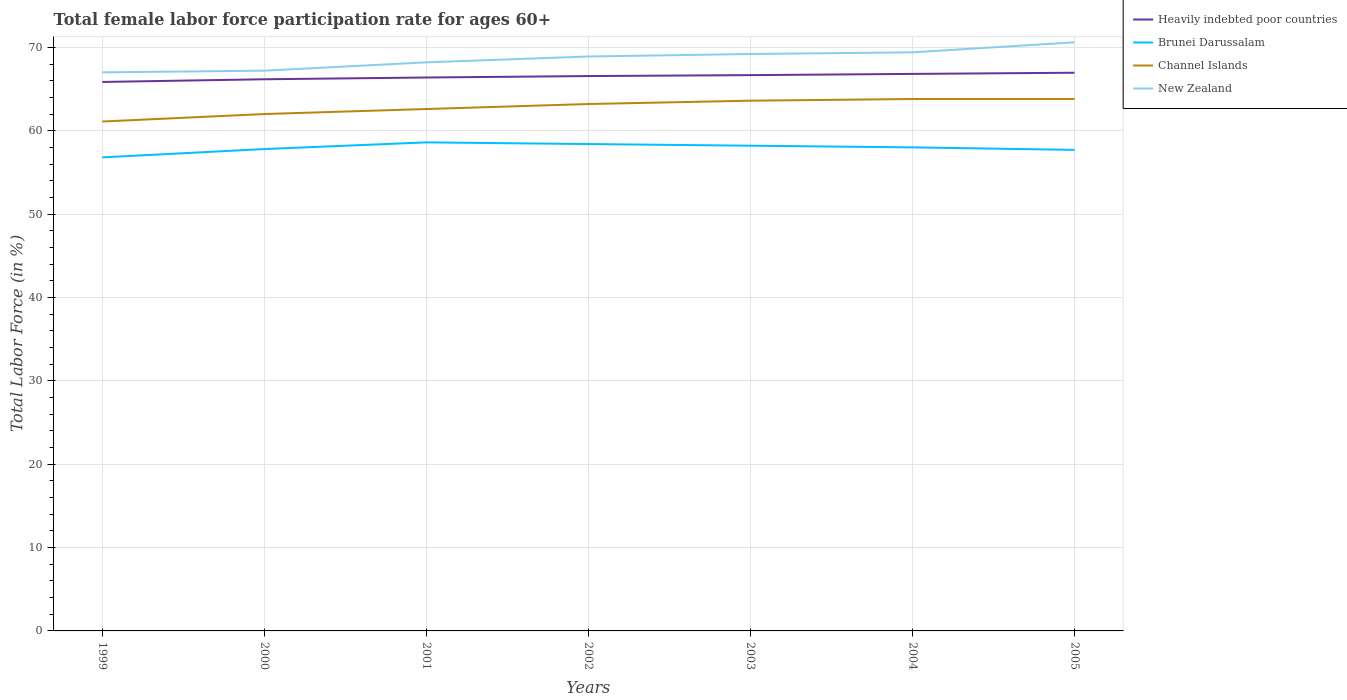Does the line corresponding to Brunei Darussalam intersect with the line corresponding to New Zealand?
Ensure brevity in your answer.  No. Across all years, what is the maximum female labor force participation rate in Channel Islands?
Give a very brief answer. 61.1. In which year was the female labor force participation rate in Brunei Darussalam maximum?
Provide a succinct answer. 1999. What is the total female labor force participation rate in Channel Islands in the graph?
Your response must be concise. -1.6. What is the difference between the highest and the second highest female labor force participation rate in Brunei Darussalam?
Make the answer very short. 1.8. How many lines are there?
Provide a succinct answer. 4. How many years are there in the graph?
Give a very brief answer. 7. Are the values on the major ticks of Y-axis written in scientific E-notation?
Your response must be concise. No. What is the title of the graph?
Give a very brief answer. Total female labor force participation rate for ages 60+. What is the label or title of the Y-axis?
Ensure brevity in your answer.  Total Labor Force (in %). What is the Total Labor Force (in %) of Heavily indebted poor countries in 1999?
Ensure brevity in your answer.  65.85. What is the Total Labor Force (in %) of Brunei Darussalam in 1999?
Ensure brevity in your answer.  56.8. What is the Total Labor Force (in %) of Channel Islands in 1999?
Ensure brevity in your answer.  61.1. What is the Total Labor Force (in %) of New Zealand in 1999?
Your response must be concise. 67. What is the Total Labor Force (in %) of Heavily indebted poor countries in 2000?
Provide a succinct answer. 66.17. What is the Total Labor Force (in %) of Brunei Darussalam in 2000?
Give a very brief answer. 57.8. What is the Total Labor Force (in %) of Channel Islands in 2000?
Offer a terse response. 62. What is the Total Labor Force (in %) in New Zealand in 2000?
Your response must be concise. 67.2. What is the Total Labor Force (in %) in Heavily indebted poor countries in 2001?
Offer a terse response. 66.38. What is the Total Labor Force (in %) of Brunei Darussalam in 2001?
Keep it short and to the point. 58.6. What is the Total Labor Force (in %) in Channel Islands in 2001?
Offer a terse response. 62.6. What is the Total Labor Force (in %) in New Zealand in 2001?
Make the answer very short. 68.2. What is the Total Labor Force (in %) in Heavily indebted poor countries in 2002?
Offer a terse response. 66.55. What is the Total Labor Force (in %) in Brunei Darussalam in 2002?
Offer a terse response. 58.4. What is the Total Labor Force (in %) of Channel Islands in 2002?
Ensure brevity in your answer.  63.2. What is the Total Labor Force (in %) of New Zealand in 2002?
Keep it short and to the point. 68.9. What is the Total Labor Force (in %) in Heavily indebted poor countries in 2003?
Ensure brevity in your answer.  66.67. What is the Total Labor Force (in %) of Brunei Darussalam in 2003?
Provide a succinct answer. 58.2. What is the Total Labor Force (in %) in Channel Islands in 2003?
Provide a succinct answer. 63.6. What is the Total Labor Force (in %) in New Zealand in 2003?
Ensure brevity in your answer.  69.2. What is the Total Labor Force (in %) of Heavily indebted poor countries in 2004?
Your answer should be very brief. 66.81. What is the Total Labor Force (in %) in Brunei Darussalam in 2004?
Ensure brevity in your answer.  58. What is the Total Labor Force (in %) in Channel Islands in 2004?
Keep it short and to the point. 63.8. What is the Total Labor Force (in %) in New Zealand in 2004?
Provide a succinct answer. 69.4. What is the Total Labor Force (in %) of Heavily indebted poor countries in 2005?
Ensure brevity in your answer.  66.95. What is the Total Labor Force (in %) of Brunei Darussalam in 2005?
Provide a succinct answer. 57.7. What is the Total Labor Force (in %) in Channel Islands in 2005?
Give a very brief answer. 63.8. What is the Total Labor Force (in %) in New Zealand in 2005?
Give a very brief answer. 70.6. Across all years, what is the maximum Total Labor Force (in %) in Heavily indebted poor countries?
Offer a terse response. 66.95. Across all years, what is the maximum Total Labor Force (in %) in Brunei Darussalam?
Give a very brief answer. 58.6. Across all years, what is the maximum Total Labor Force (in %) of Channel Islands?
Your answer should be very brief. 63.8. Across all years, what is the maximum Total Labor Force (in %) of New Zealand?
Ensure brevity in your answer.  70.6. Across all years, what is the minimum Total Labor Force (in %) of Heavily indebted poor countries?
Your answer should be compact. 65.85. Across all years, what is the minimum Total Labor Force (in %) of Brunei Darussalam?
Ensure brevity in your answer.  56.8. Across all years, what is the minimum Total Labor Force (in %) in Channel Islands?
Provide a succinct answer. 61.1. What is the total Total Labor Force (in %) in Heavily indebted poor countries in the graph?
Your answer should be compact. 465.38. What is the total Total Labor Force (in %) in Brunei Darussalam in the graph?
Provide a short and direct response. 405.5. What is the total Total Labor Force (in %) in Channel Islands in the graph?
Make the answer very short. 440.1. What is the total Total Labor Force (in %) of New Zealand in the graph?
Make the answer very short. 480.5. What is the difference between the Total Labor Force (in %) in Heavily indebted poor countries in 1999 and that in 2000?
Make the answer very short. -0.32. What is the difference between the Total Labor Force (in %) of Channel Islands in 1999 and that in 2000?
Give a very brief answer. -0.9. What is the difference between the Total Labor Force (in %) of New Zealand in 1999 and that in 2000?
Give a very brief answer. -0.2. What is the difference between the Total Labor Force (in %) of Heavily indebted poor countries in 1999 and that in 2001?
Provide a short and direct response. -0.53. What is the difference between the Total Labor Force (in %) in Channel Islands in 1999 and that in 2001?
Your response must be concise. -1.5. What is the difference between the Total Labor Force (in %) of New Zealand in 1999 and that in 2001?
Provide a succinct answer. -1.2. What is the difference between the Total Labor Force (in %) of Heavily indebted poor countries in 1999 and that in 2002?
Ensure brevity in your answer.  -0.71. What is the difference between the Total Labor Force (in %) in Channel Islands in 1999 and that in 2002?
Give a very brief answer. -2.1. What is the difference between the Total Labor Force (in %) of New Zealand in 1999 and that in 2002?
Keep it short and to the point. -1.9. What is the difference between the Total Labor Force (in %) in Heavily indebted poor countries in 1999 and that in 2003?
Give a very brief answer. -0.82. What is the difference between the Total Labor Force (in %) of New Zealand in 1999 and that in 2003?
Your answer should be very brief. -2.2. What is the difference between the Total Labor Force (in %) in Heavily indebted poor countries in 1999 and that in 2004?
Offer a terse response. -0.96. What is the difference between the Total Labor Force (in %) in Channel Islands in 1999 and that in 2004?
Give a very brief answer. -2.7. What is the difference between the Total Labor Force (in %) of New Zealand in 1999 and that in 2004?
Provide a short and direct response. -2.4. What is the difference between the Total Labor Force (in %) in Heavily indebted poor countries in 1999 and that in 2005?
Keep it short and to the point. -1.11. What is the difference between the Total Labor Force (in %) in Brunei Darussalam in 1999 and that in 2005?
Make the answer very short. -0.9. What is the difference between the Total Labor Force (in %) of New Zealand in 1999 and that in 2005?
Provide a short and direct response. -3.6. What is the difference between the Total Labor Force (in %) in Heavily indebted poor countries in 2000 and that in 2001?
Provide a short and direct response. -0.21. What is the difference between the Total Labor Force (in %) of Brunei Darussalam in 2000 and that in 2001?
Your response must be concise. -0.8. What is the difference between the Total Labor Force (in %) of Heavily indebted poor countries in 2000 and that in 2002?
Offer a very short reply. -0.38. What is the difference between the Total Labor Force (in %) of Brunei Darussalam in 2000 and that in 2002?
Make the answer very short. -0.6. What is the difference between the Total Labor Force (in %) of Heavily indebted poor countries in 2000 and that in 2003?
Make the answer very short. -0.5. What is the difference between the Total Labor Force (in %) of Brunei Darussalam in 2000 and that in 2003?
Provide a succinct answer. -0.4. What is the difference between the Total Labor Force (in %) of Channel Islands in 2000 and that in 2003?
Your response must be concise. -1.6. What is the difference between the Total Labor Force (in %) of Heavily indebted poor countries in 2000 and that in 2004?
Keep it short and to the point. -0.64. What is the difference between the Total Labor Force (in %) of Brunei Darussalam in 2000 and that in 2004?
Ensure brevity in your answer.  -0.2. What is the difference between the Total Labor Force (in %) of New Zealand in 2000 and that in 2004?
Ensure brevity in your answer.  -2.2. What is the difference between the Total Labor Force (in %) of Heavily indebted poor countries in 2000 and that in 2005?
Make the answer very short. -0.78. What is the difference between the Total Labor Force (in %) of Channel Islands in 2000 and that in 2005?
Provide a short and direct response. -1.8. What is the difference between the Total Labor Force (in %) in New Zealand in 2000 and that in 2005?
Ensure brevity in your answer.  -3.4. What is the difference between the Total Labor Force (in %) in Heavily indebted poor countries in 2001 and that in 2002?
Your answer should be very brief. -0.17. What is the difference between the Total Labor Force (in %) in Heavily indebted poor countries in 2001 and that in 2003?
Give a very brief answer. -0.29. What is the difference between the Total Labor Force (in %) of Channel Islands in 2001 and that in 2003?
Make the answer very short. -1. What is the difference between the Total Labor Force (in %) in New Zealand in 2001 and that in 2003?
Make the answer very short. -1. What is the difference between the Total Labor Force (in %) in Heavily indebted poor countries in 2001 and that in 2004?
Provide a succinct answer. -0.43. What is the difference between the Total Labor Force (in %) in Channel Islands in 2001 and that in 2004?
Offer a terse response. -1.2. What is the difference between the Total Labor Force (in %) of Heavily indebted poor countries in 2001 and that in 2005?
Your response must be concise. -0.57. What is the difference between the Total Labor Force (in %) of New Zealand in 2001 and that in 2005?
Your answer should be compact. -2.4. What is the difference between the Total Labor Force (in %) in Heavily indebted poor countries in 2002 and that in 2003?
Keep it short and to the point. -0.11. What is the difference between the Total Labor Force (in %) in Brunei Darussalam in 2002 and that in 2003?
Give a very brief answer. 0.2. What is the difference between the Total Labor Force (in %) of Heavily indebted poor countries in 2002 and that in 2004?
Offer a terse response. -0.26. What is the difference between the Total Labor Force (in %) in Brunei Darussalam in 2002 and that in 2004?
Provide a succinct answer. 0.4. What is the difference between the Total Labor Force (in %) of Channel Islands in 2002 and that in 2004?
Give a very brief answer. -0.6. What is the difference between the Total Labor Force (in %) of Heavily indebted poor countries in 2002 and that in 2005?
Offer a terse response. -0.4. What is the difference between the Total Labor Force (in %) in Channel Islands in 2002 and that in 2005?
Your response must be concise. -0.6. What is the difference between the Total Labor Force (in %) of New Zealand in 2002 and that in 2005?
Your response must be concise. -1.7. What is the difference between the Total Labor Force (in %) in Heavily indebted poor countries in 2003 and that in 2004?
Offer a terse response. -0.15. What is the difference between the Total Labor Force (in %) in Brunei Darussalam in 2003 and that in 2004?
Offer a terse response. 0.2. What is the difference between the Total Labor Force (in %) in Channel Islands in 2003 and that in 2004?
Ensure brevity in your answer.  -0.2. What is the difference between the Total Labor Force (in %) of New Zealand in 2003 and that in 2004?
Your answer should be very brief. -0.2. What is the difference between the Total Labor Force (in %) in Heavily indebted poor countries in 2003 and that in 2005?
Provide a short and direct response. -0.29. What is the difference between the Total Labor Force (in %) of New Zealand in 2003 and that in 2005?
Keep it short and to the point. -1.4. What is the difference between the Total Labor Force (in %) of Heavily indebted poor countries in 2004 and that in 2005?
Give a very brief answer. -0.14. What is the difference between the Total Labor Force (in %) in Brunei Darussalam in 2004 and that in 2005?
Your answer should be very brief. 0.3. What is the difference between the Total Labor Force (in %) in Channel Islands in 2004 and that in 2005?
Your answer should be compact. 0. What is the difference between the Total Labor Force (in %) of New Zealand in 2004 and that in 2005?
Offer a terse response. -1.2. What is the difference between the Total Labor Force (in %) of Heavily indebted poor countries in 1999 and the Total Labor Force (in %) of Brunei Darussalam in 2000?
Your response must be concise. 8.05. What is the difference between the Total Labor Force (in %) of Heavily indebted poor countries in 1999 and the Total Labor Force (in %) of Channel Islands in 2000?
Your answer should be very brief. 3.85. What is the difference between the Total Labor Force (in %) in Heavily indebted poor countries in 1999 and the Total Labor Force (in %) in New Zealand in 2000?
Provide a short and direct response. -1.35. What is the difference between the Total Labor Force (in %) of Brunei Darussalam in 1999 and the Total Labor Force (in %) of Channel Islands in 2000?
Your answer should be very brief. -5.2. What is the difference between the Total Labor Force (in %) in Brunei Darussalam in 1999 and the Total Labor Force (in %) in New Zealand in 2000?
Keep it short and to the point. -10.4. What is the difference between the Total Labor Force (in %) of Heavily indebted poor countries in 1999 and the Total Labor Force (in %) of Brunei Darussalam in 2001?
Ensure brevity in your answer.  7.25. What is the difference between the Total Labor Force (in %) of Heavily indebted poor countries in 1999 and the Total Labor Force (in %) of Channel Islands in 2001?
Your response must be concise. 3.25. What is the difference between the Total Labor Force (in %) in Heavily indebted poor countries in 1999 and the Total Labor Force (in %) in New Zealand in 2001?
Your response must be concise. -2.35. What is the difference between the Total Labor Force (in %) in Brunei Darussalam in 1999 and the Total Labor Force (in %) in Channel Islands in 2001?
Your response must be concise. -5.8. What is the difference between the Total Labor Force (in %) of Brunei Darussalam in 1999 and the Total Labor Force (in %) of New Zealand in 2001?
Your answer should be very brief. -11.4. What is the difference between the Total Labor Force (in %) of Heavily indebted poor countries in 1999 and the Total Labor Force (in %) of Brunei Darussalam in 2002?
Offer a very short reply. 7.45. What is the difference between the Total Labor Force (in %) of Heavily indebted poor countries in 1999 and the Total Labor Force (in %) of Channel Islands in 2002?
Provide a succinct answer. 2.65. What is the difference between the Total Labor Force (in %) in Heavily indebted poor countries in 1999 and the Total Labor Force (in %) in New Zealand in 2002?
Give a very brief answer. -3.05. What is the difference between the Total Labor Force (in %) in Brunei Darussalam in 1999 and the Total Labor Force (in %) in Channel Islands in 2002?
Provide a succinct answer. -6.4. What is the difference between the Total Labor Force (in %) in Brunei Darussalam in 1999 and the Total Labor Force (in %) in New Zealand in 2002?
Make the answer very short. -12.1. What is the difference between the Total Labor Force (in %) of Heavily indebted poor countries in 1999 and the Total Labor Force (in %) of Brunei Darussalam in 2003?
Offer a terse response. 7.65. What is the difference between the Total Labor Force (in %) in Heavily indebted poor countries in 1999 and the Total Labor Force (in %) in Channel Islands in 2003?
Give a very brief answer. 2.25. What is the difference between the Total Labor Force (in %) of Heavily indebted poor countries in 1999 and the Total Labor Force (in %) of New Zealand in 2003?
Your answer should be very brief. -3.35. What is the difference between the Total Labor Force (in %) in Brunei Darussalam in 1999 and the Total Labor Force (in %) in Channel Islands in 2003?
Your response must be concise. -6.8. What is the difference between the Total Labor Force (in %) in Brunei Darussalam in 1999 and the Total Labor Force (in %) in New Zealand in 2003?
Offer a very short reply. -12.4. What is the difference between the Total Labor Force (in %) of Channel Islands in 1999 and the Total Labor Force (in %) of New Zealand in 2003?
Make the answer very short. -8.1. What is the difference between the Total Labor Force (in %) in Heavily indebted poor countries in 1999 and the Total Labor Force (in %) in Brunei Darussalam in 2004?
Keep it short and to the point. 7.85. What is the difference between the Total Labor Force (in %) of Heavily indebted poor countries in 1999 and the Total Labor Force (in %) of Channel Islands in 2004?
Your response must be concise. 2.05. What is the difference between the Total Labor Force (in %) of Heavily indebted poor countries in 1999 and the Total Labor Force (in %) of New Zealand in 2004?
Your response must be concise. -3.55. What is the difference between the Total Labor Force (in %) in Brunei Darussalam in 1999 and the Total Labor Force (in %) in New Zealand in 2004?
Ensure brevity in your answer.  -12.6. What is the difference between the Total Labor Force (in %) of Heavily indebted poor countries in 1999 and the Total Labor Force (in %) of Brunei Darussalam in 2005?
Offer a terse response. 8.15. What is the difference between the Total Labor Force (in %) of Heavily indebted poor countries in 1999 and the Total Labor Force (in %) of Channel Islands in 2005?
Provide a succinct answer. 2.05. What is the difference between the Total Labor Force (in %) in Heavily indebted poor countries in 1999 and the Total Labor Force (in %) in New Zealand in 2005?
Provide a short and direct response. -4.75. What is the difference between the Total Labor Force (in %) in Channel Islands in 1999 and the Total Labor Force (in %) in New Zealand in 2005?
Keep it short and to the point. -9.5. What is the difference between the Total Labor Force (in %) of Heavily indebted poor countries in 2000 and the Total Labor Force (in %) of Brunei Darussalam in 2001?
Give a very brief answer. 7.57. What is the difference between the Total Labor Force (in %) of Heavily indebted poor countries in 2000 and the Total Labor Force (in %) of Channel Islands in 2001?
Your answer should be very brief. 3.57. What is the difference between the Total Labor Force (in %) in Heavily indebted poor countries in 2000 and the Total Labor Force (in %) in New Zealand in 2001?
Your answer should be very brief. -2.03. What is the difference between the Total Labor Force (in %) in Brunei Darussalam in 2000 and the Total Labor Force (in %) in Channel Islands in 2001?
Provide a succinct answer. -4.8. What is the difference between the Total Labor Force (in %) of Channel Islands in 2000 and the Total Labor Force (in %) of New Zealand in 2001?
Provide a short and direct response. -6.2. What is the difference between the Total Labor Force (in %) in Heavily indebted poor countries in 2000 and the Total Labor Force (in %) in Brunei Darussalam in 2002?
Your answer should be compact. 7.77. What is the difference between the Total Labor Force (in %) of Heavily indebted poor countries in 2000 and the Total Labor Force (in %) of Channel Islands in 2002?
Offer a very short reply. 2.97. What is the difference between the Total Labor Force (in %) in Heavily indebted poor countries in 2000 and the Total Labor Force (in %) in New Zealand in 2002?
Your answer should be compact. -2.73. What is the difference between the Total Labor Force (in %) in Channel Islands in 2000 and the Total Labor Force (in %) in New Zealand in 2002?
Your answer should be very brief. -6.9. What is the difference between the Total Labor Force (in %) in Heavily indebted poor countries in 2000 and the Total Labor Force (in %) in Brunei Darussalam in 2003?
Give a very brief answer. 7.97. What is the difference between the Total Labor Force (in %) in Heavily indebted poor countries in 2000 and the Total Labor Force (in %) in Channel Islands in 2003?
Make the answer very short. 2.57. What is the difference between the Total Labor Force (in %) in Heavily indebted poor countries in 2000 and the Total Labor Force (in %) in New Zealand in 2003?
Offer a terse response. -3.03. What is the difference between the Total Labor Force (in %) of Channel Islands in 2000 and the Total Labor Force (in %) of New Zealand in 2003?
Provide a short and direct response. -7.2. What is the difference between the Total Labor Force (in %) of Heavily indebted poor countries in 2000 and the Total Labor Force (in %) of Brunei Darussalam in 2004?
Keep it short and to the point. 8.17. What is the difference between the Total Labor Force (in %) in Heavily indebted poor countries in 2000 and the Total Labor Force (in %) in Channel Islands in 2004?
Offer a terse response. 2.37. What is the difference between the Total Labor Force (in %) of Heavily indebted poor countries in 2000 and the Total Labor Force (in %) of New Zealand in 2004?
Your answer should be compact. -3.23. What is the difference between the Total Labor Force (in %) of Brunei Darussalam in 2000 and the Total Labor Force (in %) of New Zealand in 2004?
Give a very brief answer. -11.6. What is the difference between the Total Labor Force (in %) in Channel Islands in 2000 and the Total Labor Force (in %) in New Zealand in 2004?
Keep it short and to the point. -7.4. What is the difference between the Total Labor Force (in %) in Heavily indebted poor countries in 2000 and the Total Labor Force (in %) in Brunei Darussalam in 2005?
Offer a terse response. 8.47. What is the difference between the Total Labor Force (in %) of Heavily indebted poor countries in 2000 and the Total Labor Force (in %) of Channel Islands in 2005?
Provide a succinct answer. 2.37. What is the difference between the Total Labor Force (in %) of Heavily indebted poor countries in 2000 and the Total Labor Force (in %) of New Zealand in 2005?
Ensure brevity in your answer.  -4.43. What is the difference between the Total Labor Force (in %) of Channel Islands in 2000 and the Total Labor Force (in %) of New Zealand in 2005?
Make the answer very short. -8.6. What is the difference between the Total Labor Force (in %) of Heavily indebted poor countries in 2001 and the Total Labor Force (in %) of Brunei Darussalam in 2002?
Provide a succinct answer. 7.98. What is the difference between the Total Labor Force (in %) in Heavily indebted poor countries in 2001 and the Total Labor Force (in %) in Channel Islands in 2002?
Ensure brevity in your answer.  3.18. What is the difference between the Total Labor Force (in %) of Heavily indebted poor countries in 2001 and the Total Labor Force (in %) of New Zealand in 2002?
Give a very brief answer. -2.52. What is the difference between the Total Labor Force (in %) of Brunei Darussalam in 2001 and the Total Labor Force (in %) of Channel Islands in 2002?
Provide a succinct answer. -4.6. What is the difference between the Total Labor Force (in %) of Brunei Darussalam in 2001 and the Total Labor Force (in %) of New Zealand in 2002?
Provide a short and direct response. -10.3. What is the difference between the Total Labor Force (in %) in Channel Islands in 2001 and the Total Labor Force (in %) in New Zealand in 2002?
Your answer should be compact. -6.3. What is the difference between the Total Labor Force (in %) of Heavily indebted poor countries in 2001 and the Total Labor Force (in %) of Brunei Darussalam in 2003?
Your answer should be compact. 8.18. What is the difference between the Total Labor Force (in %) of Heavily indebted poor countries in 2001 and the Total Labor Force (in %) of Channel Islands in 2003?
Your answer should be very brief. 2.78. What is the difference between the Total Labor Force (in %) in Heavily indebted poor countries in 2001 and the Total Labor Force (in %) in New Zealand in 2003?
Provide a succinct answer. -2.82. What is the difference between the Total Labor Force (in %) of Brunei Darussalam in 2001 and the Total Labor Force (in %) of New Zealand in 2003?
Make the answer very short. -10.6. What is the difference between the Total Labor Force (in %) of Channel Islands in 2001 and the Total Labor Force (in %) of New Zealand in 2003?
Provide a short and direct response. -6.6. What is the difference between the Total Labor Force (in %) of Heavily indebted poor countries in 2001 and the Total Labor Force (in %) of Brunei Darussalam in 2004?
Your answer should be very brief. 8.38. What is the difference between the Total Labor Force (in %) in Heavily indebted poor countries in 2001 and the Total Labor Force (in %) in Channel Islands in 2004?
Offer a very short reply. 2.58. What is the difference between the Total Labor Force (in %) of Heavily indebted poor countries in 2001 and the Total Labor Force (in %) of New Zealand in 2004?
Give a very brief answer. -3.02. What is the difference between the Total Labor Force (in %) of Brunei Darussalam in 2001 and the Total Labor Force (in %) of Channel Islands in 2004?
Give a very brief answer. -5.2. What is the difference between the Total Labor Force (in %) of Channel Islands in 2001 and the Total Labor Force (in %) of New Zealand in 2004?
Give a very brief answer. -6.8. What is the difference between the Total Labor Force (in %) of Heavily indebted poor countries in 2001 and the Total Labor Force (in %) of Brunei Darussalam in 2005?
Your answer should be compact. 8.68. What is the difference between the Total Labor Force (in %) of Heavily indebted poor countries in 2001 and the Total Labor Force (in %) of Channel Islands in 2005?
Make the answer very short. 2.58. What is the difference between the Total Labor Force (in %) of Heavily indebted poor countries in 2001 and the Total Labor Force (in %) of New Zealand in 2005?
Ensure brevity in your answer.  -4.22. What is the difference between the Total Labor Force (in %) of Channel Islands in 2001 and the Total Labor Force (in %) of New Zealand in 2005?
Offer a very short reply. -8. What is the difference between the Total Labor Force (in %) in Heavily indebted poor countries in 2002 and the Total Labor Force (in %) in Brunei Darussalam in 2003?
Provide a short and direct response. 8.35. What is the difference between the Total Labor Force (in %) in Heavily indebted poor countries in 2002 and the Total Labor Force (in %) in Channel Islands in 2003?
Keep it short and to the point. 2.95. What is the difference between the Total Labor Force (in %) of Heavily indebted poor countries in 2002 and the Total Labor Force (in %) of New Zealand in 2003?
Offer a very short reply. -2.65. What is the difference between the Total Labor Force (in %) in Heavily indebted poor countries in 2002 and the Total Labor Force (in %) in Brunei Darussalam in 2004?
Ensure brevity in your answer.  8.55. What is the difference between the Total Labor Force (in %) of Heavily indebted poor countries in 2002 and the Total Labor Force (in %) of Channel Islands in 2004?
Provide a short and direct response. 2.75. What is the difference between the Total Labor Force (in %) of Heavily indebted poor countries in 2002 and the Total Labor Force (in %) of New Zealand in 2004?
Your response must be concise. -2.85. What is the difference between the Total Labor Force (in %) of Brunei Darussalam in 2002 and the Total Labor Force (in %) of Channel Islands in 2004?
Offer a very short reply. -5.4. What is the difference between the Total Labor Force (in %) in Heavily indebted poor countries in 2002 and the Total Labor Force (in %) in Brunei Darussalam in 2005?
Make the answer very short. 8.85. What is the difference between the Total Labor Force (in %) in Heavily indebted poor countries in 2002 and the Total Labor Force (in %) in Channel Islands in 2005?
Give a very brief answer. 2.75. What is the difference between the Total Labor Force (in %) of Heavily indebted poor countries in 2002 and the Total Labor Force (in %) of New Zealand in 2005?
Your response must be concise. -4.05. What is the difference between the Total Labor Force (in %) of Brunei Darussalam in 2002 and the Total Labor Force (in %) of Channel Islands in 2005?
Your answer should be very brief. -5.4. What is the difference between the Total Labor Force (in %) in Brunei Darussalam in 2002 and the Total Labor Force (in %) in New Zealand in 2005?
Your answer should be very brief. -12.2. What is the difference between the Total Labor Force (in %) of Channel Islands in 2002 and the Total Labor Force (in %) of New Zealand in 2005?
Provide a short and direct response. -7.4. What is the difference between the Total Labor Force (in %) in Heavily indebted poor countries in 2003 and the Total Labor Force (in %) in Brunei Darussalam in 2004?
Offer a very short reply. 8.67. What is the difference between the Total Labor Force (in %) in Heavily indebted poor countries in 2003 and the Total Labor Force (in %) in Channel Islands in 2004?
Your answer should be compact. 2.87. What is the difference between the Total Labor Force (in %) of Heavily indebted poor countries in 2003 and the Total Labor Force (in %) of New Zealand in 2004?
Provide a short and direct response. -2.73. What is the difference between the Total Labor Force (in %) in Channel Islands in 2003 and the Total Labor Force (in %) in New Zealand in 2004?
Your response must be concise. -5.8. What is the difference between the Total Labor Force (in %) in Heavily indebted poor countries in 2003 and the Total Labor Force (in %) in Brunei Darussalam in 2005?
Offer a very short reply. 8.97. What is the difference between the Total Labor Force (in %) in Heavily indebted poor countries in 2003 and the Total Labor Force (in %) in Channel Islands in 2005?
Your answer should be compact. 2.87. What is the difference between the Total Labor Force (in %) in Heavily indebted poor countries in 2003 and the Total Labor Force (in %) in New Zealand in 2005?
Your answer should be compact. -3.93. What is the difference between the Total Labor Force (in %) in Channel Islands in 2003 and the Total Labor Force (in %) in New Zealand in 2005?
Give a very brief answer. -7. What is the difference between the Total Labor Force (in %) in Heavily indebted poor countries in 2004 and the Total Labor Force (in %) in Brunei Darussalam in 2005?
Keep it short and to the point. 9.11. What is the difference between the Total Labor Force (in %) in Heavily indebted poor countries in 2004 and the Total Labor Force (in %) in Channel Islands in 2005?
Offer a terse response. 3.01. What is the difference between the Total Labor Force (in %) in Heavily indebted poor countries in 2004 and the Total Labor Force (in %) in New Zealand in 2005?
Your response must be concise. -3.79. What is the difference between the Total Labor Force (in %) of Channel Islands in 2004 and the Total Labor Force (in %) of New Zealand in 2005?
Ensure brevity in your answer.  -6.8. What is the average Total Labor Force (in %) in Heavily indebted poor countries per year?
Make the answer very short. 66.48. What is the average Total Labor Force (in %) of Brunei Darussalam per year?
Offer a terse response. 57.93. What is the average Total Labor Force (in %) of Channel Islands per year?
Offer a very short reply. 62.87. What is the average Total Labor Force (in %) in New Zealand per year?
Your answer should be very brief. 68.64. In the year 1999, what is the difference between the Total Labor Force (in %) of Heavily indebted poor countries and Total Labor Force (in %) of Brunei Darussalam?
Make the answer very short. 9.05. In the year 1999, what is the difference between the Total Labor Force (in %) in Heavily indebted poor countries and Total Labor Force (in %) in Channel Islands?
Keep it short and to the point. 4.75. In the year 1999, what is the difference between the Total Labor Force (in %) in Heavily indebted poor countries and Total Labor Force (in %) in New Zealand?
Provide a short and direct response. -1.15. In the year 1999, what is the difference between the Total Labor Force (in %) of Brunei Darussalam and Total Labor Force (in %) of Channel Islands?
Ensure brevity in your answer.  -4.3. In the year 2000, what is the difference between the Total Labor Force (in %) of Heavily indebted poor countries and Total Labor Force (in %) of Brunei Darussalam?
Your response must be concise. 8.37. In the year 2000, what is the difference between the Total Labor Force (in %) in Heavily indebted poor countries and Total Labor Force (in %) in Channel Islands?
Provide a succinct answer. 4.17. In the year 2000, what is the difference between the Total Labor Force (in %) of Heavily indebted poor countries and Total Labor Force (in %) of New Zealand?
Offer a terse response. -1.03. In the year 2000, what is the difference between the Total Labor Force (in %) of Brunei Darussalam and Total Labor Force (in %) of New Zealand?
Give a very brief answer. -9.4. In the year 2000, what is the difference between the Total Labor Force (in %) of Channel Islands and Total Labor Force (in %) of New Zealand?
Ensure brevity in your answer.  -5.2. In the year 2001, what is the difference between the Total Labor Force (in %) in Heavily indebted poor countries and Total Labor Force (in %) in Brunei Darussalam?
Make the answer very short. 7.78. In the year 2001, what is the difference between the Total Labor Force (in %) of Heavily indebted poor countries and Total Labor Force (in %) of Channel Islands?
Your response must be concise. 3.78. In the year 2001, what is the difference between the Total Labor Force (in %) of Heavily indebted poor countries and Total Labor Force (in %) of New Zealand?
Offer a very short reply. -1.82. In the year 2001, what is the difference between the Total Labor Force (in %) in Brunei Darussalam and Total Labor Force (in %) in Channel Islands?
Your answer should be very brief. -4. In the year 2002, what is the difference between the Total Labor Force (in %) in Heavily indebted poor countries and Total Labor Force (in %) in Brunei Darussalam?
Make the answer very short. 8.15. In the year 2002, what is the difference between the Total Labor Force (in %) of Heavily indebted poor countries and Total Labor Force (in %) of Channel Islands?
Your answer should be very brief. 3.35. In the year 2002, what is the difference between the Total Labor Force (in %) of Heavily indebted poor countries and Total Labor Force (in %) of New Zealand?
Your answer should be very brief. -2.35. In the year 2003, what is the difference between the Total Labor Force (in %) of Heavily indebted poor countries and Total Labor Force (in %) of Brunei Darussalam?
Your answer should be compact. 8.47. In the year 2003, what is the difference between the Total Labor Force (in %) of Heavily indebted poor countries and Total Labor Force (in %) of Channel Islands?
Your answer should be very brief. 3.07. In the year 2003, what is the difference between the Total Labor Force (in %) of Heavily indebted poor countries and Total Labor Force (in %) of New Zealand?
Offer a terse response. -2.53. In the year 2003, what is the difference between the Total Labor Force (in %) in Brunei Darussalam and Total Labor Force (in %) in New Zealand?
Your response must be concise. -11. In the year 2004, what is the difference between the Total Labor Force (in %) in Heavily indebted poor countries and Total Labor Force (in %) in Brunei Darussalam?
Keep it short and to the point. 8.81. In the year 2004, what is the difference between the Total Labor Force (in %) of Heavily indebted poor countries and Total Labor Force (in %) of Channel Islands?
Make the answer very short. 3.01. In the year 2004, what is the difference between the Total Labor Force (in %) in Heavily indebted poor countries and Total Labor Force (in %) in New Zealand?
Provide a short and direct response. -2.59. In the year 2004, what is the difference between the Total Labor Force (in %) in Brunei Darussalam and Total Labor Force (in %) in Channel Islands?
Your answer should be very brief. -5.8. In the year 2004, what is the difference between the Total Labor Force (in %) of Channel Islands and Total Labor Force (in %) of New Zealand?
Your answer should be very brief. -5.6. In the year 2005, what is the difference between the Total Labor Force (in %) of Heavily indebted poor countries and Total Labor Force (in %) of Brunei Darussalam?
Offer a terse response. 9.25. In the year 2005, what is the difference between the Total Labor Force (in %) in Heavily indebted poor countries and Total Labor Force (in %) in Channel Islands?
Your response must be concise. 3.15. In the year 2005, what is the difference between the Total Labor Force (in %) of Heavily indebted poor countries and Total Labor Force (in %) of New Zealand?
Provide a succinct answer. -3.65. In the year 2005, what is the difference between the Total Labor Force (in %) in Channel Islands and Total Labor Force (in %) in New Zealand?
Ensure brevity in your answer.  -6.8. What is the ratio of the Total Labor Force (in %) of Heavily indebted poor countries in 1999 to that in 2000?
Ensure brevity in your answer.  1. What is the ratio of the Total Labor Force (in %) of Brunei Darussalam in 1999 to that in 2000?
Your answer should be compact. 0.98. What is the ratio of the Total Labor Force (in %) of Channel Islands in 1999 to that in 2000?
Give a very brief answer. 0.99. What is the ratio of the Total Labor Force (in %) in Brunei Darussalam in 1999 to that in 2001?
Ensure brevity in your answer.  0.97. What is the ratio of the Total Labor Force (in %) of New Zealand in 1999 to that in 2001?
Ensure brevity in your answer.  0.98. What is the ratio of the Total Labor Force (in %) of Heavily indebted poor countries in 1999 to that in 2002?
Offer a terse response. 0.99. What is the ratio of the Total Labor Force (in %) in Brunei Darussalam in 1999 to that in 2002?
Offer a very short reply. 0.97. What is the ratio of the Total Labor Force (in %) of Channel Islands in 1999 to that in 2002?
Keep it short and to the point. 0.97. What is the ratio of the Total Labor Force (in %) of New Zealand in 1999 to that in 2002?
Give a very brief answer. 0.97. What is the ratio of the Total Labor Force (in %) of Heavily indebted poor countries in 1999 to that in 2003?
Give a very brief answer. 0.99. What is the ratio of the Total Labor Force (in %) of Brunei Darussalam in 1999 to that in 2003?
Your answer should be compact. 0.98. What is the ratio of the Total Labor Force (in %) in Channel Islands in 1999 to that in 2003?
Your answer should be compact. 0.96. What is the ratio of the Total Labor Force (in %) of New Zealand in 1999 to that in 2003?
Offer a terse response. 0.97. What is the ratio of the Total Labor Force (in %) in Heavily indebted poor countries in 1999 to that in 2004?
Give a very brief answer. 0.99. What is the ratio of the Total Labor Force (in %) in Brunei Darussalam in 1999 to that in 2004?
Provide a succinct answer. 0.98. What is the ratio of the Total Labor Force (in %) of Channel Islands in 1999 to that in 2004?
Offer a terse response. 0.96. What is the ratio of the Total Labor Force (in %) in New Zealand in 1999 to that in 2004?
Offer a very short reply. 0.97. What is the ratio of the Total Labor Force (in %) of Heavily indebted poor countries in 1999 to that in 2005?
Provide a succinct answer. 0.98. What is the ratio of the Total Labor Force (in %) in Brunei Darussalam in 1999 to that in 2005?
Your answer should be very brief. 0.98. What is the ratio of the Total Labor Force (in %) in Channel Islands in 1999 to that in 2005?
Provide a succinct answer. 0.96. What is the ratio of the Total Labor Force (in %) in New Zealand in 1999 to that in 2005?
Your answer should be compact. 0.95. What is the ratio of the Total Labor Force (in %) in Heavily indebted poor countries in 2000 to that in 2001?
Provide a succinct answer. 1. What is the ratio of the Total Labor Force (in %) of Brunei Darussalam in 2000 to that in 2001?
Your response must be concise. 0.99. What is the ratio of the Total Labor Force (in %) in New Zealand in 2000 to that in 2001?
Keep it short and to the point. 0.99. What is the ratio of the Total Labor Force (in %) in Heavily indebted poor countries in 2000 to that in 2002?
Provide a succinct answer. 0.99. What is the ratio of the Total Labor Force (in %) of Channel Islands in 2000 to that in 2002?
Your response must be concise. 0.98. What is the ratio of the Total Labor Force (in %) of New Zealand in 2000 to that in 2002?
Offer a very short reply. 0.98. What is the ratio of the Total Labor Force (in %) of Heavily indebted poor countries in 2000 to that in 2003?
Provide a succinct answer. 0.99. What is the ratio of the Total Labor Force (in %) of Channel Islands in 2000 to that in 2003?
Provide a succinct answer. 0.97. What is the ratio of the Total Labor Force (in %) of New Zealand in 2000 to that in 2003?
Offer a terse response. 0.97. What is the ratio of the Total Labor Force (in %) in Heavily indebted poor countries in 2000 to that in 2004?
Your answer should be very brief. 0.99. What is the ratio of the Total Labor Force (in %) of Channel Islands in 2000 to that in 2004?
Make the answer very short. 0.97. What is the ratio of the Total Labor Force (in %) of New Zealand in 2000 to that in 2004?
Keep it short and to the point. 0.97. What is the ratio of the Total Labor Force (in %) in Heavily indebted poor countries in 2000 to that in 2005?
Give a very brief answer. 0.99. What is the ratio of the Total Labor Force (in %) of Brunei Darussalam in 2000 to that in 2005?
Provide a short and direct response. 1. What is the ratio of the Total Labor Force (in %) of Channel Islands in 2000 to that in 2005?
Your answer should be very brief. 0.97. What is the ratio of the Total Labor Force (in %) of New Zealand in 2000 to that in 2005?
Offer a terse response. 0.95. What is the ratio of the Total Labor Force (in %) of Heavily indebted poor countries in 2001 to that in 2002?
Ensure brevity in your answer.  1. What is the ratio of the Total Labor Force (in %) of Heavily indebted poor countries in 2001 to that in 2003?
Offer a very short reply. 1. What is the ratio of the Total Labor Force (in %) of Channel Islands in 2001 to that in 2003?
Keep it short and to the point. 0.98. What is the ratio of the Total Labor Force (in %) in New Zealand in 2001 to that in 2003?
Provide a short and direct response. 0.99. What is the ratio of the Total Labor Force (in %) of Brunei Darussalam in 2001 to that in 2004?
Provide a succinct answer. 1.01. What is the ratio of the Total Labor Force (in %) in Channel Islands in 2001 to that in 2004?
Give a very brief answer. 0.98. What is the ratio of the Total Labor Force (in %) in New Zealand in 2001 to that in 2004?
Your answer should be compact. 0.98. What is the ratio of the Total Labor Force (in %) in Brunei Darussalam in 2001 to that in 2005?
Your response must be concise. 1.02. What is the ratio of the Total Labor Force (in %) of Channel Islands in 2001 to that in 2005?
Offer a terse response. 0.98. What is the ratio of the Total Labor Force (in %) of New Zealand in 2002 to that in 2003?
Offer a very short reply. 1. What is the ratio of the Total Labor Force (in %) of Channel Islands in 2002 to that in 2004?
Give a very brief answer. 0.99. What is the ratio of the Total Labor Force (in %) of Heavily indebted poor countries in 2002 to that in 2005?
Offer a very short reply. 0.99. What is the ratio of the Total Labor Force (in %) of Brunei Darussalam in 2002 to that in 2005?
Provide a succinct answer. 1.01. What is the ratio of the Total Labor Force (in %) of Channel Islands in 2002 to that in 2005?
Provide a short and direct response. 0.99. What is the ratio of the Total Labor Force (in %) of New Zealand in 2002 to that in 2005?
Your answer should be very brief. 0.98. What is the ratio of the Total Labor Force (in %) in Heavily indebted poor countries in 2003 to that in 2004?
Provide a short and direct response. 1. What is the ratio of the Total Labor Force (in %) in Brunei Darussalam in 2003 to that in 2004?
Your answer should be compact. 1. What is the ratio of the Total Labor Force (in %) in New Zealand in 2003 to that in 2004?
Provide a short and direct response. 1. What is the ratio of the Total Labor Force (in %) in Brunei Darussalam in 2003 to that in 2005?
Your answer should be compact. 1.01. What is the ratio of the Total Labor Force (in %) in Channel Islands in 2003 to that in 2005?
Keep it short and to the point. 1. What is the ratio of the Total Labor Force (in %) of New Zealand in 2003 to that in 2005?
Offer a very short reply. 0.98. What is the ratio of the Total Labor Force (in %) in Channel Islands in 2004 to that in 2005?
Offer a very short reply. 1. What is the ratio of the Total Labor Force (in %) in New Zealand in 2004 to that in 2005?
Provide a succinct answer. 0.98. What is the difference between the highest and the second highest Total Labor Force (in %) of Heavily indebted poor countries?
Offer a terse response. 0.14. What is the difference between the highest and the lowest Total Labor Force (in %) in Heavily indebted poor countries?
Provide a succinct answer. 1.11. 